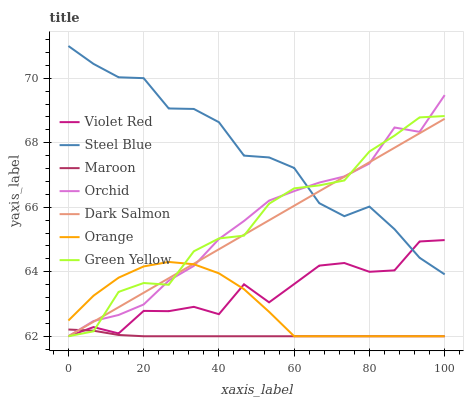Does Maroon have the minimum area under the curve?
Answer yes or no. Yes. Does Steel Blue have the maximum area under the curve?
Answer yes or no. Yes. Does Dark Salmon have the minimum area under the curve?
Answer yes or no. No. Does Dark Salmon have the maximum area under the curve?
Answer yes or no. No. Is Dark Salmon the smoothest?
Answer yes or no. Yes. Is Violet Red the roughest?
Answer yes or no. Yes. Is Maroon the smoothest?
Answer yes or no. No. Is Maroon the roughest?
Answer yes or no. No. Does Steel Blue have the lowest value?
Answer yes or no. No. Does Steel Blue have the highest value?
Answer yes or no. Yes. Does Dark Salmon have the highest value?
Answer yes or no. No. Is Maroon less than Steel Blue?
Answer yes or no. Yes. Is Steel Blue greater than Maroon?
Answer yes or no. Yes. Does Dark Salmon intersect Steel Blue?
Answer yes or no. Yes. Is Dark Salmon less than Steel Blue?
Answer yes or no. No. Is Dark Salmon greater than Steel Blue?
Answer yes or no. No. Does Maroon intersect Steel Blue?
Answer yes or no. No. 